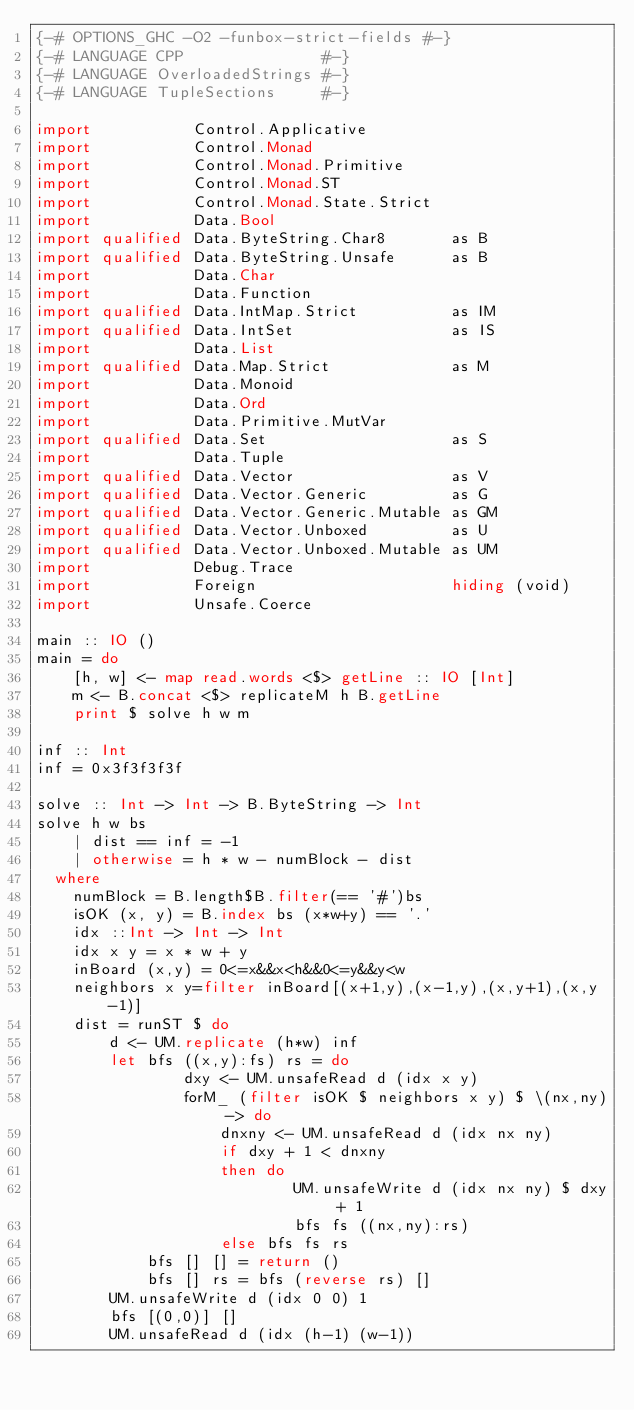<code> <loc_0><loc_0><loc_500><loc_500><_Haskell_>{-# OPTIONS_GHC -O2 -funbox-strict-fields #-}
{-# LANGUAGE CPP               #-}
{-# LANGUAGE OverloadedStrings #-}
{-# LANGUAGE TupleSections     #-}

import           Control.Applicative
import           Control.Monad
import           Control.Monad.Primitive
import           Control.Monad.ST
import           Control.Monad.State.Strict
import           Data.Bool
import qualified Data.ByteString.Char8       as B
import qualified Data.ByteString.Unsafe      as B
import           Data.Char
import           Data.Function
import qualified Data.IntMap.Strict          as IM
import qualified Data.IntSet                 as IS
import           Data.List
import qualified Data.Map.Strict             as M
import           Data.Monoid
import           Data.Ord
import           Data.Primitive.MutVar
import qualified Data.Set                    as S
import           Data.Tuple
import qualified Data.Vector                 as V
import qualified Data.Vector.Generic         as G
import qualified Data.Vector.Generic.Mutable as GM
import qualified Data.Vector.Unboxed         as U
import qualified Data.Vector.Unboxed.Mutable as UM
import           Debug.Trace
import           Foreign                     hiding (void)
import           Unsafe.Coerce

main :: IO ()
main = do
    [h, w] <- map read.words <$> getLine :: IO [Int]
    m <- B.concat <$> replicateM h B.getLine
    print $ solve h w m

inf :: Int
inf = 0x3f3f3f3f

solve :: Int -> Int -> B.ByteString -> Int
solve h w bs
    | dist == inf = -1
    | otherwise = h * w - numBlock - dist
  where
    numBlock = B.length$B.filter(== '#')bs
    isOK (x, y) = B.index bs (x*w+y) == '.'
    idx ::Int -> Int -> Int
    idx x y = x * w + y
    inBoard (x,y) = 0<=x&&x<h&&0<=y&&y<w
    neighbors x y=filter inBoard[(x+1,y),(x-1,y),(x,y+1),(x,y-1)]
    dist = runST $ do
        d <- UM.replicate (h*w) inf
        let bfs ((x,y):fs) rs = do
                dxy <- UM.unsafeRead d (idx x y)
                forM_ (filter isOK $ neighbors x y) $ \(nx,ny) -> do
                    dnxny <- UM.unsafeRead d (idx nx ny)
                    if dxy + 1 < dnxny
                    then do
                            UM.unsafeWrite d (idx nx ny) $ dxy + 1
                            bfs fs ((nx,ny):rs)
                    else bfs fs rs
            bfs [] [] = return ()
            bfs [] rs = bfs (reverse rs) []
        UM.unsafeWrite d (idx 0 0) 1
        bfs [(0,0)] []
        UM.unsafeRead d (idx (h-1) (w-1))

</code> 